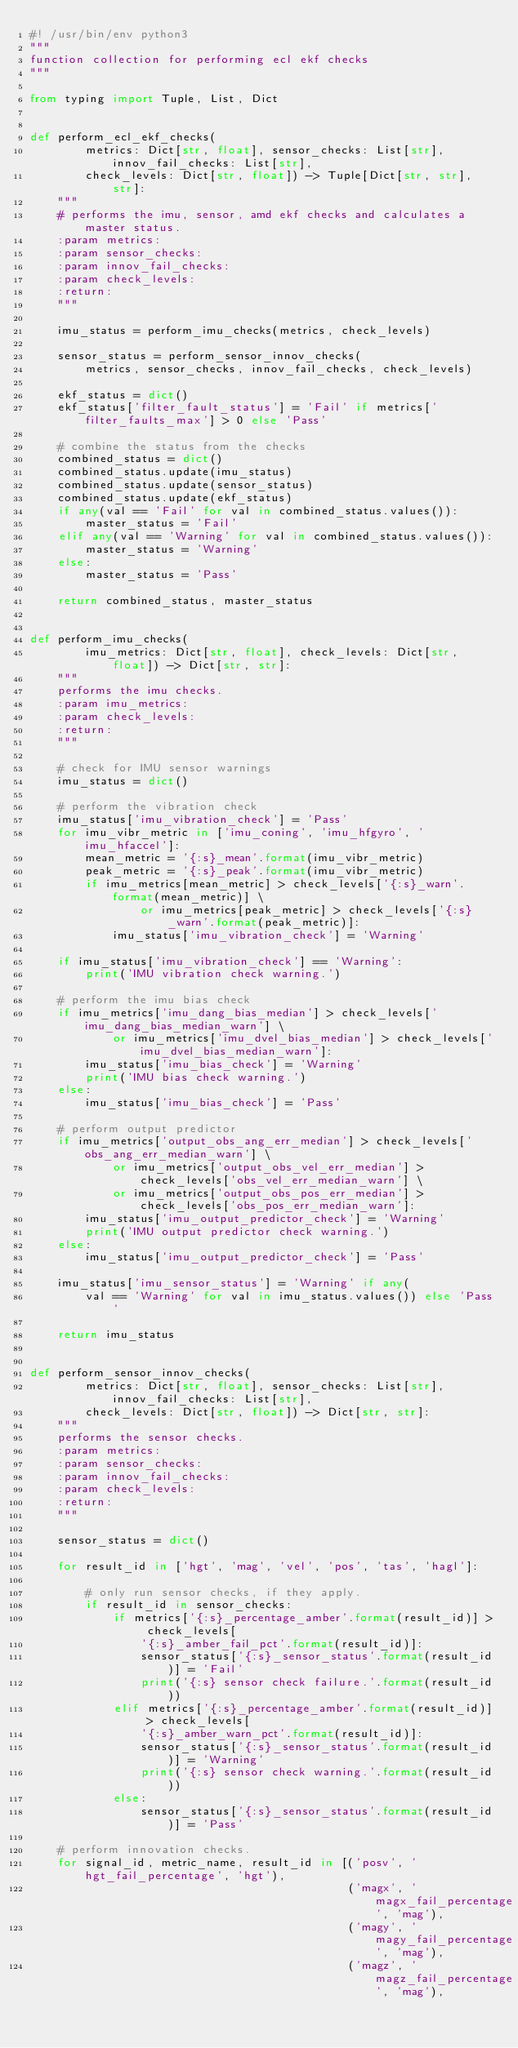<code> <loc_0><loc_0><loc_500><loc_500><_Python_>#! /usr/bin/env python3
"""
function collection for performing ecl ekf checks
"""

from typing import Tuple, List, Dict


def perform_ecl_ekf_checks(
        metrics: Dict[str, float], sensor_checks: List[str], innov_fail_checks: List[str],
        check_levels: Dict[str, float]) -> Tuple[Dict[str, str], str]:
    """
    # performs the imu, sensor, amd ekf checks and calculates a master status.
    :param metrics:
    :param sensor_checks:
    :param innov_fail_checks:
    :param check_levels:
    :return:
    """

    imu_status = perform_imu_checks(metrics, check_levels)

    sensor_status = perform_sensor_innov_checks(
        metrics, sensor_checks, innov_fail_checks, check_levels)

    ekf_status = dict()
    ekf_status['filter_fault_status'] = 'Fail' if metrics['filter_faults_max'] > 0 else 'Pass'

    # combine the status from the checks
    combined_status = dict()
    combined_status.update(imu_status)
    combined_status.update(sensor_status)
    combined_status.update(ekf_status)
    if any(val == 'Fail' for val in combined_status.values()):
        master_status = 'Fail'
    elif any(val == 'Warning' for val in combined_status.values()):
        master_status = 'Warning'
    else:
        master_status = 'Pass'

    return combined_status, master_status


def perform_imu_checks(
        imu_metrics: Dict[str, float], check_levels: Dict[str, float]) -> Dict[str, str]:
    """
    performs the imu checks.
    :param imu_metrics:
    :param check_levels:
    :return:
    """

    # check for IMU sensor warnings
    imu_status = dict()

    # perform the vibration check
    imu_status['imu_vibration_check'] = 'Pass'
    for imu_vibr_metric in ['imu_coning', 'imu_hfgyro', 'imu_hfaccel']:
        mean_metric = '{:s}_mean'.format(imu_vibr_metric)
        peak_metric = '{:s}_peak'.format(imu_vibr_metric)
        if imu_metrics[mean_metric] > check_levels['{:s}_warn'.format(mean_metric)] \
                or imu_metrics[peak_metric] > check_levels['{:s}_warn'.format(peak_metric)]:
            imu_status['imu_vibration_check'] = 'Warning'

    if imu_status['imu_vibration_check'] == 'Warning':
        print('IMU vibration check warning.')

    # perform the imu bias check
    if imu_metrics['imu_dang_bias_median'] > check_levels['imu_dang_bias_median_warn'] \
            or imu_metrics['imu_dvel_bias_median'] > check_levels['imu_dvel_bias_median_warn']:
        imu_status['imu_bias_check'] = 'Warning'
        print('IMU bias check warning.')
    else:
        imu_status['imu_bias_check'] = 'Pass'

    # perform output predictor
    if imu_metrics['output_obs_ang_err_median'] > check_levels['obs_ang_err_median_warn'] \
            or imu_metrics['output_obs_vel_err_median'] > check_levels['obs_vel_err_median_warn'] \
            or imu_metrics['output_obs_pos_err_median'] > check_levels['obs_pos_err_median_warn']:
        imu_status['imu_output_predictor_check'] = 'Warning'
        print('IMU output predictor check warning.')
    else:
        imu_status['imu_output_predictor_check'] = 'Pass'

    imu_status['imu_sensor_status'] = 'Warning' if any(
        val == 'Warning' for val in imu_status.values()) else 'Pass'

    return imu_status


def perform_sensor_innov_checks(
        metrics: Dict[str, float], sensor_checks: List[str], innov_fail_checks: List[str],
        check_levels: Dict[str, float]) -> Dict[str, str]:
    """
    performs the sensor checks.
    :param metrics:
    :param sensor_checks:
    :param innov_fail_checks:
    :param check_levels:
    :return:
    """

    sensor_status = dict()

    for result_id in ['hgt', 'mag', 'vel', 'pos', 'tas', 'hagl']:

        # only run sensor checks, if they apply.
        if result_id in sensor_checks:
            if metrics['{:s}_percentage_amber'.format(result_id)] > check_levels[
                '{:s}_amber_fail_pct'.format(result_id)]:
                sensor_status['{:s}_sensor_status'.format(result_id)] = 'Fail'
                print('{:s} sensor check failure.'.format(result_id))
            elif metrics['{:s}_percentage_amber'.format(result_id)] > check_levels[
                '{:s}_amber_warn_pct'.format(result_id)]:
                sensor_status['{:s}_sensor_status'.format(result_id)] = 'Warning'
                print('{:s} sensor check warning.'.format(result_id))
            else:
                sensor_status['{:s}_sensor_status'.format(result_id)] = 'Pass'

    # perform innovation checks.
    for signal_id, metric_name, result_id in [('posv', 'hgt_fail_percentage', 'hgt'),
                                              ('magx', 'magx_fail_percentage', 'mag'),
                                              ('magy', 'magy_fail_percentage', 'mag'),
                                              ('magz', 'magz_fail_percentage', 'mag'),</code> 